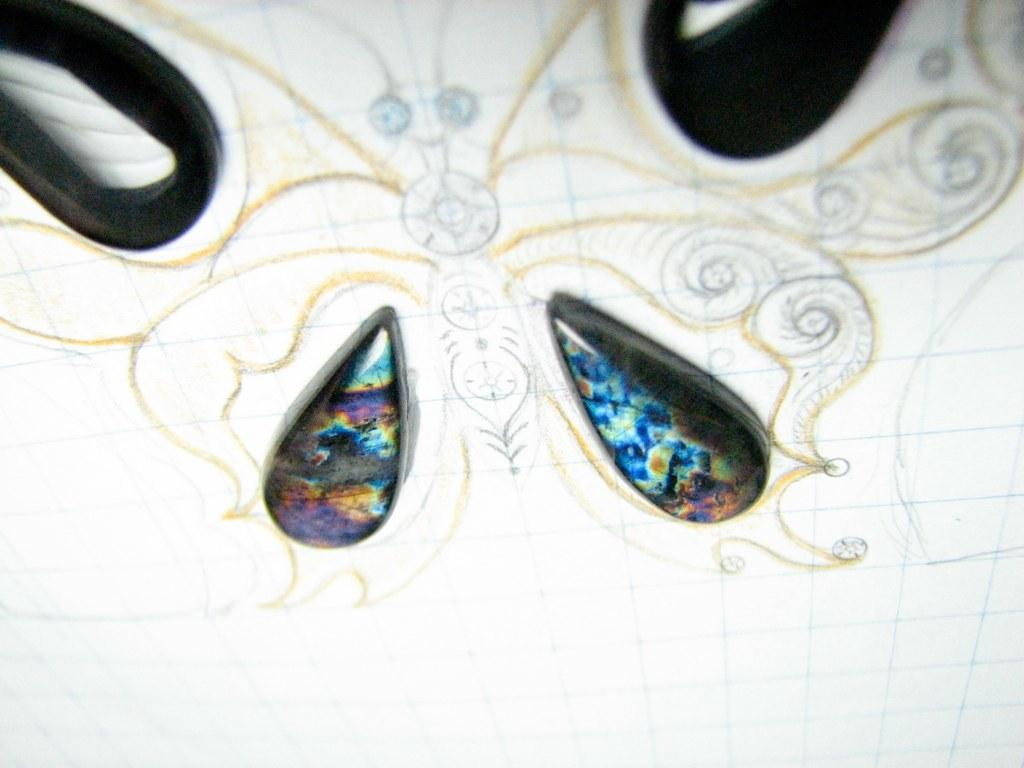What is depicted on the white paper in the image? There is a drawing on the white paper. What else can be seen on the white paper besides the drawing? There are stones on the white paper. What hobbies does the stone depicted in the image have? There is no indication of any hobbies for the stone, as it is an inanimate object and does not have hobbies. 